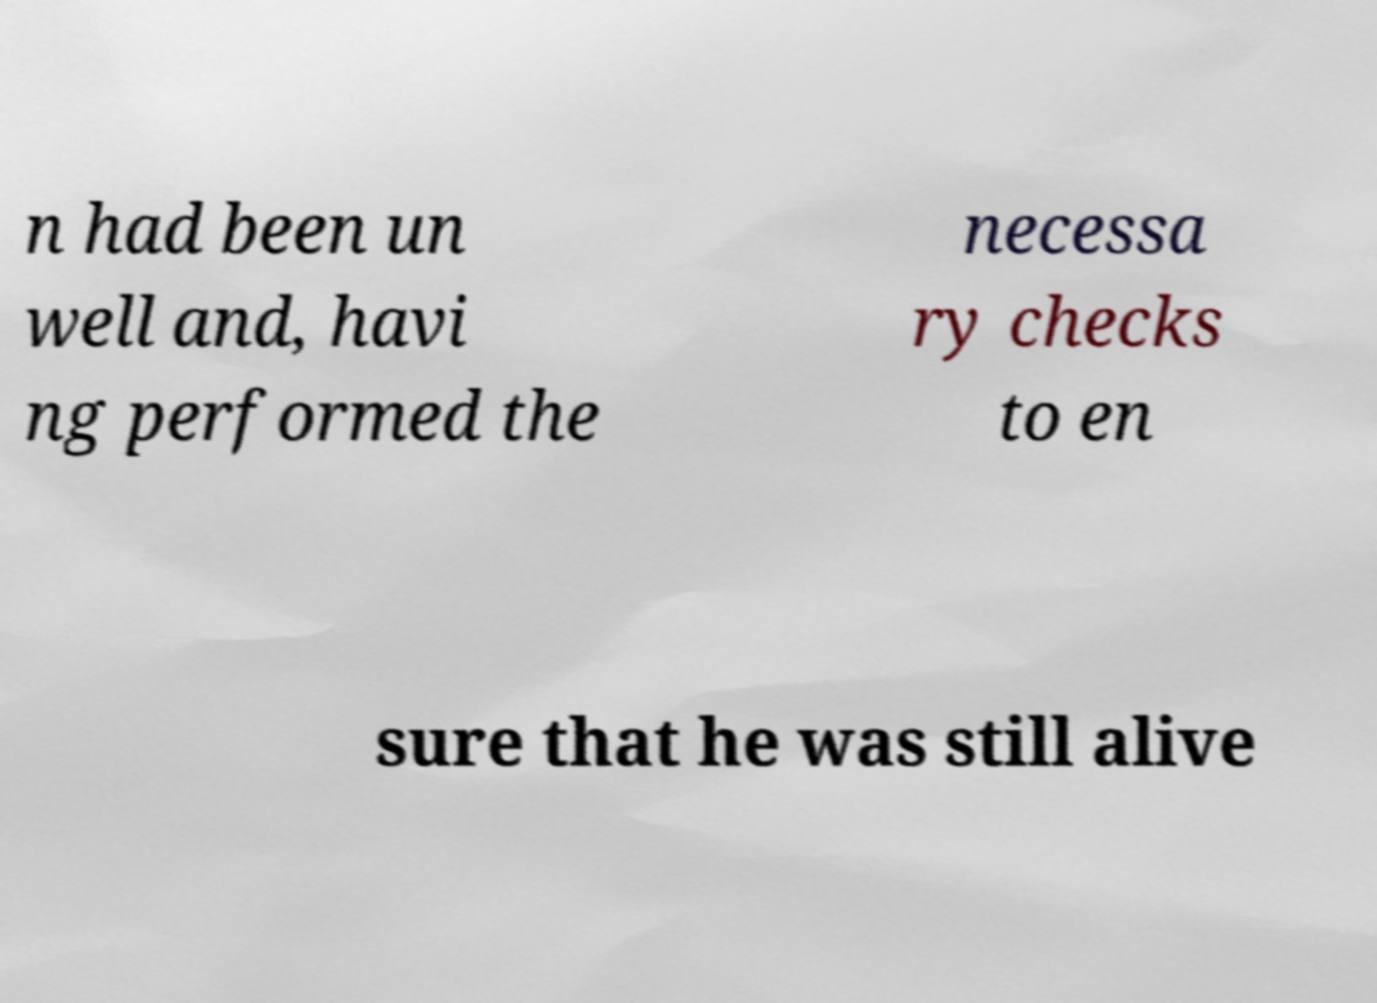Please identify and transcribe the text found in this image. n had been un well and, havi ng performed the necessa ry checks to en sure that he was still alive 